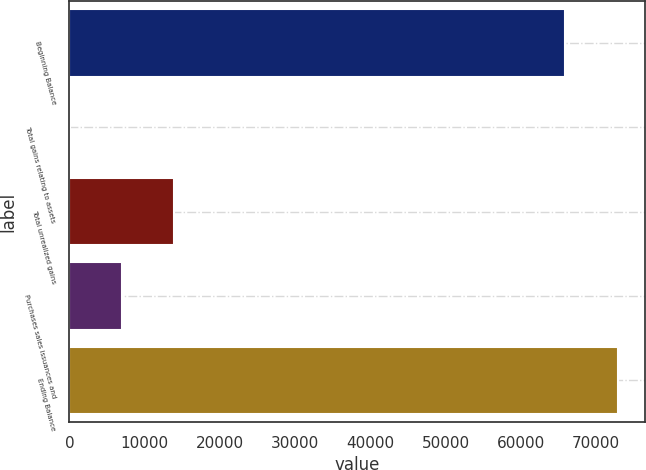<chart> <loc_0><loc_0><loc_500><loc_500><bar_chart><fcel>Beginning Balance<fcel>Total gains relating to assets<fcel>Total unrealized gains<fcel>Purchases sales issuances and<fcel>Ending Balance<nl><fcel>65902<fcel>79<fcel>13943<fcel>7011<fcel>72834<nl></chart> 